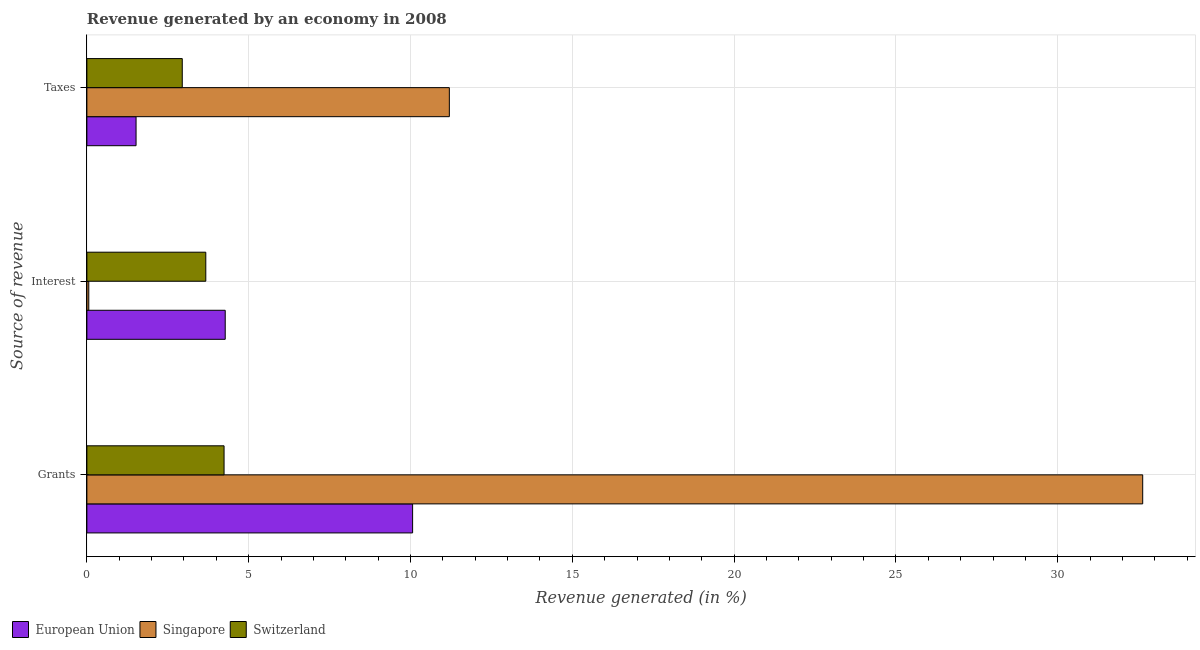Are the number of bars per tick equal to the number of legend labels?
Your answer should be very brief. Yes. Are the number of bars on each tick of the Y-axis equal?
Ensure brevity in your answer.  Yes. What is the label of the 1st group of bars from the top?
Ensure brevity in your answer.  Taxes. What is the percentage of revenue generated by grants in European Union?
Offer a very short reply. 10.07. Across all countries, what is the maximum percentage of revenue generated by taxes?
Your answer should be very brief. 11.2. Across all countries, what is the minimum percentage of revenue generated by taxes?
Provide a succinct answer. 1.52. In which country was the percentage of revenue generated by interest maximum?
Your answer should be compact. European Union. In which country was the percentage of revenue generated by grants minimum?
Offer a terse response. Switzerland. What is the total percentage of revenue generated by grants in the graph?
Give a very brief answer. 46.93. What is the difference between the percentage of revenue generated by grants in European Union and that in Singapore?
Give a very brief answer. -22.56. What is the difference between the percentage of revenue generated by interest in Switzerland and the percentage of revenue generated by taxes in European Union?
Ensure brevity in your answer.  2.15. What is the average percentage of revenue generated by grants per country?
Your answer should be compact. 15.64. What is the difference between the percentage of revenue generated by interest and percentage of revenue generated by taxes in European Union?
Make the answer very short. 2.76. What is the ratio of the percentage of revenue generated by taxes in Switzerland to that in European Union?
Offer a terse response. 1.94. Is the percentage of revenue generated by interest in European Union less than that in Singapore?
Offer a terse response. No. Is the difference between the percentage of revenue generated by taxes in Singapore and Switzerland greater than the difference between the percentage of revenue generated by interest in Singapore and Switzerland?
Make the answer very short. Yes. What is the difference between the highest and the second highest percentage of revenue generated by taxes?
Offer a terse response. 8.25. What is the difference between the highest and the lowest percentage of revenue generated by grants?
Provide a succinct answer. 28.39. What does the 2nd bar from the top in Interest represents?
Your answer should be very brief. Singapore. What does the 3rd bar from the bottom in Grants represents?
Provide a succinct answer. Switzerland. What is the difference between two consecutive major ticks on the X-axis?
Make the answer very short. 5. Are the values on the major ticks of X-axis written in scientific E-notation?
Make the answer very short. No. Does the graph contain any zero values?
Make the answer very short. No. How are the legend labels stacked?
Offer a very short reply. Horizontal. What is the title of the graph?
Your answer should be very brief. Revenue generated by an economy in 2008. Does "Low income" appear as one of the legend labels in the graph?
Your response must be concise. No. What is the label or title of the X-axis?
Offer a terse response. Revenue generated (in %). What is the label or title of the Y-axis?
Offer a terse response. Source of revenue. What is the Revenue generated (in %) of European Union in Grants?
Offer a very short reply. 10.07. What is the Revenue generated (in %) in Singapore in Grants?
Your response must be concise. 32.63. What is the Revenue generated (in %) in Switzerland in Grants?
Provide a short and direct response. 4.24. What is the Revenue generated (in %) of European Union in Interest?
Keep it short and to the point. 4.28. What is the Revenue generated (in %) of Singapore in Interest?
Your answer should be very brief. 0.06. What is the Revenue generated (in %) of Switzerland in Interest?
Make the answer very short. 3.67. What is the Revenue generated (in %) in European Union in Taxes?
Your response must be concise. 1.52. What is the Revenue generated (in %) of Singapore in Taxes?
Make the answer very short. 11.2. What is the Revenue generated (in %) in Switzerland in Taxes?
Offer a very short reply. 2.95. Across all Source of revenue, what is the maximum Revenue generated (in %) of European Union?
Your response must be concise. 10.07. Across all Source of revenue, what is the maximum Revenue generated (in %) of Singapore?
Make the answer very short. 32.63. Across all Source of revenue, what is the maximum Revenue generated (in %) of Switzerland?
Offer a terse response. 4.24. Across all Source of revenue, what is the minimum Revenue generated (in %) in European Union?
Your response must be concise. 1.52. Across all Source of revenue, what is the minimum Revenue generated (in %) in Singapore?
Ensure brevity in your answer.  0.06. Across all Source of revenue, what is the minimum Revenue generated (in %) of Switzerland?
Offer a terse response. 2.95. What is the total Revenue generated (in %) in European Union in the graph?
Provide a short and direct response. 15.86. What is the total Revenue generated (in %) in Singapore in the graph?
Ensure brevity in your answer.  43.89. What is the total Revenue generated (in %) of Switzerland in the graph?
Your response must be concise. 10.86. What is the difference between the Revenue generated (in %) in European Union in Grants and that in Interest?
Your response must be concise. 5.79. What is the difference between the Revenue generated (in %) in Singapore in Grants and that in Interest?
Keep it short and to the point. 32.57. What is the difference between the Revenue generated (in %) in Switzerland in Grants and that in Interest?
Keep it short and to the point. 0.56. What is the difference between the Revenue generated (in %) in European Union in Grants and that in Taxes?
Provide a succinct answer. 8.55. What is the difference between the Revenue generated (in %) in Singapore in Grants and that in Taxes?
Make the answer very short. 21.43. What is the difference between the Revenue generated (in %) of Switzerland in Grants and that in Taxes?
Your response must be concise. 1.29. What is the difference between the Revenue generated (in %) of European Union in Interest and that in Taxes?
Your response must be concise. 2.76. What is the difference between the Revenue generated (in %) of Singapore in Interest and that in Taxes?
Provide a short and direct response. -11.14. What is the difference between the Revenue generated (in %) of Switzerland in Interest and that in Taxes?
Make the answer very short. 0.73. What is the difference between the Revenue generated (in %) in European Union in Grants and the Revenue generated (in %) in Singapore in Interest?
Make the answer very short. 10.01. What is the difference between the Revenue generated (in %) in European Union in Grants and the Revenue generated (in %) in Switzerland in Interest?
Ensure brevity in your answer.  6.39. What is the difference between the Revenue generated (in %) of Singapore in Grants and the Revenue generated (in %) of Switzerland in Interest?
Keep it short and to the point. 28.95. What is the difference between the Revenue generated (in %) of European Union in Grants and the Revenue generated (in %) of Singapore in Taxes?
Offer a very short reply. -1.14. What is the difference between the Revenue generated (in %) in European Union in Grants and the Revenue generated (in %) in Switzerland in Taxes?
Provide a short and direct response. 7.12. What is the difference between the Revenue generated (in %) of Singapore in Grants and the Revenue generated (in %) of Switzerland in Taxes?
Your answer should be compact. 29.68. What is the difference between the Revenue generated (in %) of European Union in Interest and the Revenue generated (in %) of Singapore in Taxes?
Offer a terse response. -6.93. What is the difference between the Revenue generated (in %) in European Union in Interest and the Revenue generated (in %) in Switzerland in Taxes?
Offer a terse response. 1.33. What is the difference between the Revenue generated (in %) of Singapore in Interest and the Revenue generated (in %) of Switzerland in Taxes?
Give a very brief answer. -2.89. What is the average Revenue generated (in %) of European Union per Source of revenue?
Your answer should be very brief. 5.29. What is the average Revenue generated (in %) in Singapore per Source of revenue?
Offer a terse response. 14.63. What is the average Revenue generated (in %) of Switzerland per Source of revenue?
Keep it short and to the point. 3.62. What is the difference between the Revenue generated (in %) in European Union and Revenue generated (in %) in Singapore in Grants?
Provide a succinct answer. -22.56. What is the difference between the Revenue generated (in %) in European Union and Revenue generated (in %) in Switzerland in Grants?
Provide a succinct answer. 5.83. What is the difference between the Revenue generated (in %) in Singapore and Revenue generated (in %) in Switzerland in Grants?
Your answer should be compact. 28.39. What is the difference between the Revenue generated (in %) in European Union and Revenue generated (in %) in Singapore in Interest?
Keep it short and to the point. 4.22. What is the difference between the Revenue generated (in %) in European Union and Revenue generated (in %) in Switzerland in Interest?
Make the answer very short. 0.6. What is the difference between the Revenue generated (in %) of Singapore and Revenue generated (in %) of Switzerland in Interest?
Provide a succinct answer. -3.62. What is the difference between the Revenue generated (in %) in European Union and Revenue generated (in %) in Singapore in Taxes?
Your answer should be compact. -9.68. What is the difference between the Revenue generated (in %) of European Union and Revenue generated (in %) of Switzerland in Taxes?
Your answer should be very brief. -1.43. What is the difference between the Revenue generated (in %) in Singapore and Revenue generated (in %) in Switzerland in Taxes?
Ensure brevity in your answer.  8.25. What is the ratio of the Revenue generated (in %) in European Union in Grants to that in Interest?
Your answer should be very brief. 2.35. What is the ratio of the Revenue generated (in %) in Singapore in Grants to that in Interest?
Give a very brief answer. 552.91. What is the ratio of the Revenue generated (in %) of Switzerland in Grants to that in Interest?
Provide a short and direct response. 1.15. What is the ratio of the Revenue generated (in %) of European Union in Grants to that in Taxes?
Keep it short and to the point. 6.62. What is the ratio of the Revenue generated (in %) in Singapore in Grants to that in Taxes?
Provide a short and direct response. 2.91. What is the ratio of the Revenue generated (in %) in Switzerland in Grants to that in Taxes?
Make the answer very short. 1.44. What is the ratio of the Revenue generated (in %) of European Union in Interest to that in Taxes?
Give a very brief answer. 2.81. What is the ratio of the Revenue generated (in %) of Singapore in Interest to that in Taxes?
Provide a short and direct response. 0.01. What is the ratio of the Revenue generated (in %) of Switzerland in Interest to that in Taxes?
Offer a very short reply. 1.25. What is the difference between the highest and the second highest Revenue generated (in %) in European Union?
Your answer should be very brief. 5.79. What is the difference between the highest and the second highest Revenue generated (in %) in Singapore?
Your answer should be compact. 21.43. What is the difference between the highest and the second highest Revenue generated (in %) of Switzerland?
Offer a terse response. 0.56. What is the difference between the highest and the lowest Revenue generated (in %) in European Union?
Offer a very short reply. 8.55. What is the difference between the highest and the lowest Revenue generated (in %) of Singapore?
Give a very brief answer. 32.57. What is the difference between the highest and the lowest Revenue generated (in %) of Switzerland?
Ensure brevity in your answer.  1.29. 